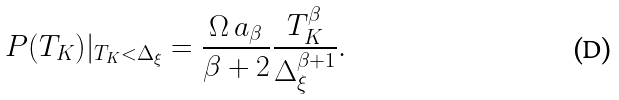Convert formula to latex. <formula><loc_0><loc_0><loc_500><loc_500>P ( T _ { K } ) | _ { T _ { K } < \Delta _ { \xi } } = \frac { \Omega \, a _ { \beta } } { \beta + 2 } \frac { T _ { K } ^ { \beta } } { \Delta _ { \xi } ^ { \beta + 1 } } .</formula> 